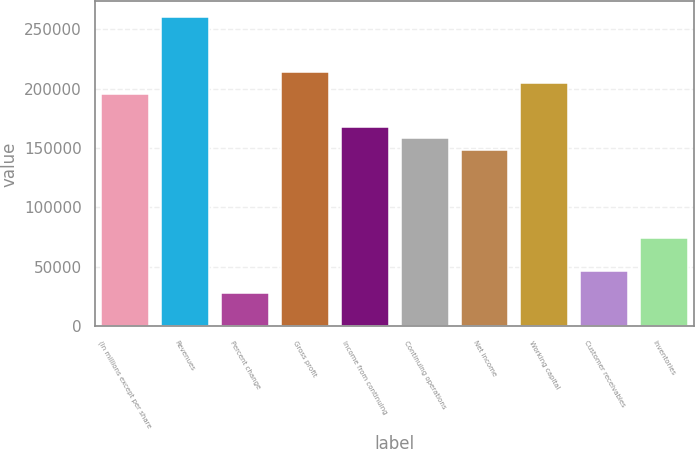<chart> <loc_0><loc_0><loc_500><loc_500><bar_chart><fcel>(In millions except per share<fcel>Revenues<fcel>Percent change<fcel>Gross profit<fcel>Income from continuing<fcel>Continuing operations<fcel>Net income<fcel>Working capital<fcel>Customer receivables<fcel>Inventories<nl><fcel>195252<fcel>260335<fcel>27893.2<fcel>213847<fcel>167359<fcel>158061<fcel>148763<fcel>204549<fcel>46488.6<fcel>74381.6<nl></chart> 